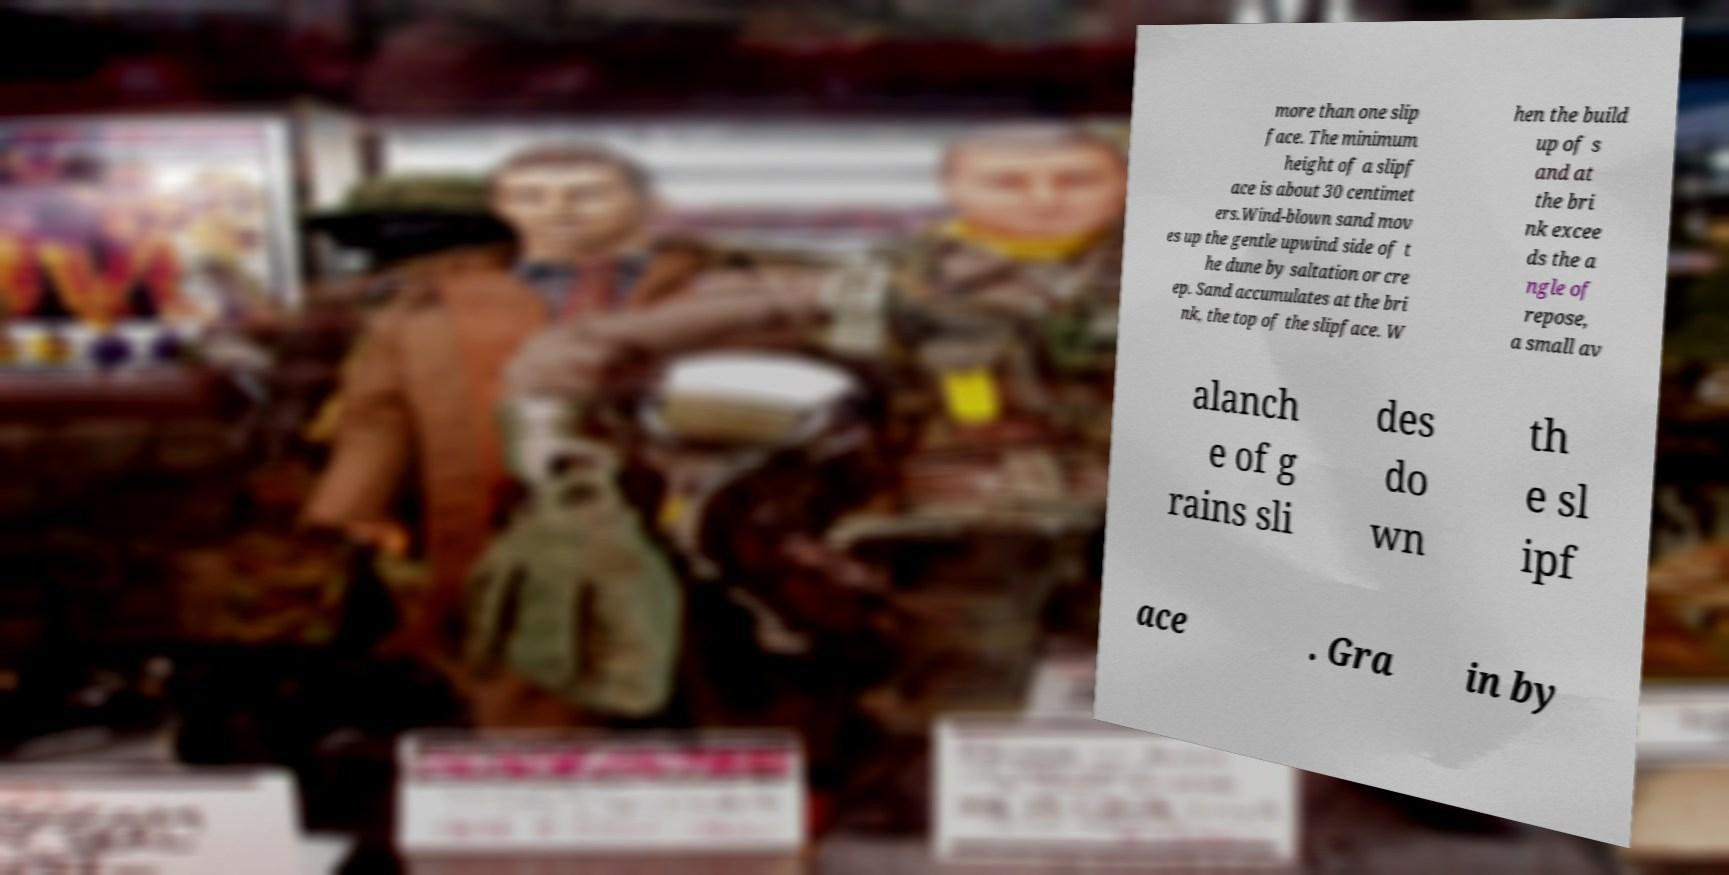Please identify and transcribe the text found in this image. more than one slip face. The minimum height of a slipf ace is about 30 centimet ers.Wind-blown sand mov es up the gentle upwind side of t he dune by saltation or cre ep. Sand accumulates at the bri nk, the top of the slipface. W hen the build up of s and at the bri nk excee ds the a ngle of repose, a small av alanch e of g rains sli des do wn th e sl ipf ace . Gra in by 